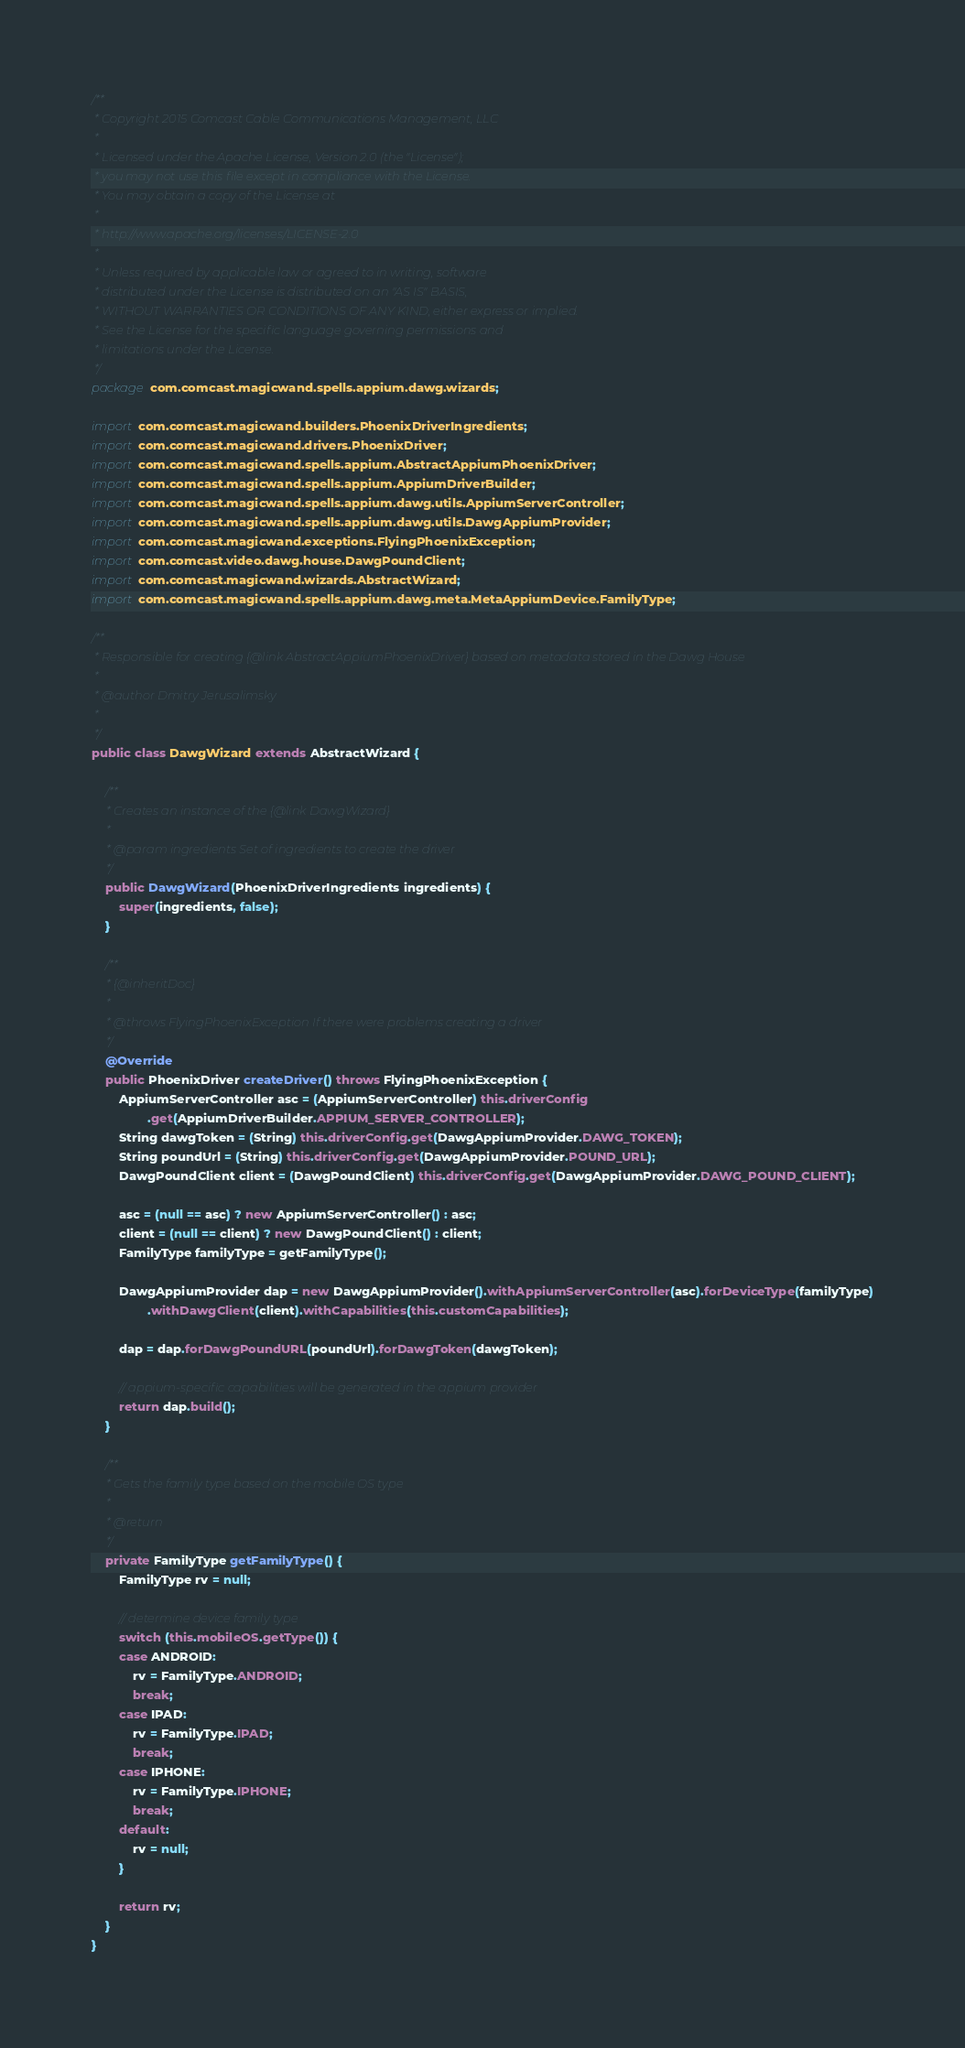<code> <loc_0><loc_0><loc_500><loc_500><_Java_>/**
 * Copyright 2015 Comcast Cable Communications Management, LLC
 *
 * Licensed under the Apache License, Version 2.0 (the "License");
 * you may not use this file except in compliance with the License.
 * You may obtain a copy of the License at
 *
 * http://www.apache.org/licenses/LICENSE-2.0
 *
 * Unless required by applicable law or agreed to in writing, software
 * distributed under the License is distributed on an "AS IS" BASIS,
 * WITHOUT WARRANTIES OR CONDITIONS OF ANY KIND, either express or implied.
 * See the License for the specific language governing permissions and
 * limitations under the License.
 */
package com.comcast.magicwand.spells.appium.dawg.wizards;

import com.comcast.magicwand.builders.PhoenixDriverIngredients;
import com.comcast.magicwand.drivers.PhoenixDriver;
import com.comcast.magicwand.spells.appium.AbstractAppiumPhoenixDriver;
import com.comcast.magicwand.spells.appium.AppiumDriverBuilder;
import com.comcast.magicwand.spells.appium.dawg.utils.AppiumServerController;
import com.comcast.magicwand.spells.appium.dawg.utils.DawgAppiumProvider;
import com.comcast.magicwand.exceptions.FlyingPhoenixException;
import com.comcast.video.dawg.house.DawgPoundClient;
import com.comcast.magicwand.wizards.AbstractWizard;
import com.comcast.magicwand.spells.appium.dawg.meta.MetaAppiumDevice.FamilyType;

/**
 * Responsible for creating {@link AbstractAppiumPhoenixDriver} based on metadata stored in the Dawg House
 *
 * @author Dmitry Jerusalimsky
 *
 */
public class DawgWizard extends AbstractWizard {

    /**
     * Creates an instance of the {@link DawgWizard}
     *
     * @param ingredients Set of ingredients to create the driver
     */
    public DawgWizard(PhoenixDriverIngredients ingredients) {
        super(ingredients, false);
    }

    /**
     * {@inheritDoc}
     *
     * @throws FlyingPhoenixException If there were problems creating a driver
     */
    @Override
    public PhoenixDriver createDriver() throws FlyingPhoenixException {
        AppiumServerController asc = (AppiumServerController) this.driverConfig
                .get(AppiumDriverBuilder.APPIUM_SERVER_CONTROLLER);
        String dawgToken = (String) this.driverConfig.get(DawgAppiumProvider.DAWG_TOKEN);
        String poundUrl = (String) this.driverConfig.get(DawgAppiumProvider.POUND_URL);
        DawgPoundClient client = (DawgPoundClient) this.driverConfig.get(DawgAppiumProvider.DAWG_POUND_CLIENT);

        asc = (null == asc) ? new AppiumServerController() : asc;
        client = (null == client) ? new DawgPoundClient() : client;
        FamilyType familyType = getFamilyType();

        DawgAppiumProvider dap = new DawgAppiumProvider().withAppiumServerController(asc).forDeviceType(familyType)
                .withDawgClient(client).withCapabilities(this.customCapabilities);

        dap = dap.forDawgPoundURL(poundUrl).forDawgToken(dawgToken);

        // appium-specific capabilities will be generated in the appium provider
        return dap.build();
    }

    /**
     * Gets the family type based on the mobile OS type
     *
     * @return
     */
    private FamilyType getFamilyType() {
        FamilyType rv = null;

        // determine device family type
        switch (this.mobileOS.getType()) {
        case ANDROID:
            rv = FamilyType.ANDROID;
            break;
        case IPAD:
            rv = FamilyType.IPAD;
            break;
        case IPHONE:
            rv = FamilyType.IPHONE;
            break;
        default:
            rv = null;
        }

        return rv;
    }
}
</code> 